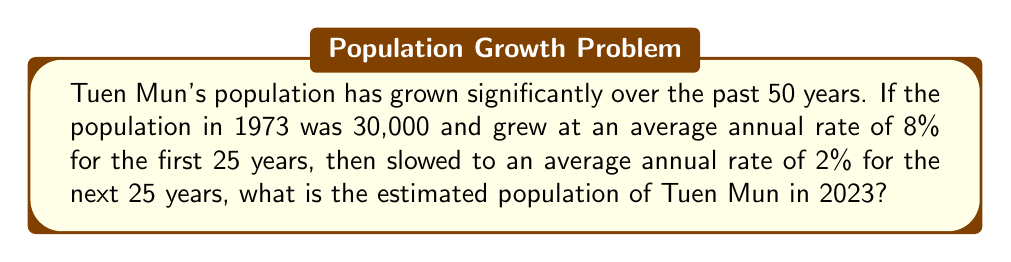Show me your answer to this math problem. Let's break this down step-by-step:

1) First, we'll calculate the population after the first 25 years (1973-1998):
   
   Initial population: $P_0 = 30,000$
   Growth rate: $r = 8\% = 0.08$
   Time: $t = 25$ years
   
   Using the compound interest formula: $P = P_0(1+r)^t$
   
   $P_{1998} = 30,000(1+0.08)^{25}$
   $P_{1998} = 30,000(1.08)^{25}$
   $P_{1998} = 30,000 \times 6.848 = 205,440$

2) Now, we'll calculate the population for the next 25 years (1998-2023):
   
   Initial population: $P_0 = 205,440$
   Growth rate: $r = 2\% = 0.02$
   Time: $t = 25$ years
   
   Using the same formula:
   
   $P_{2023} = 205,440(1+0.02)^{25}$
   $P_{2023} = 205,440(1.02)^{25}$
   $P_{2023} = 205,440 \times 1.6406 = 337,035.26$

3) Rounding to the nearest whole number:
   
   $P_{2023} \approx 337,035$
Answer: 337,035 